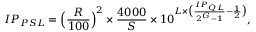<formula> <loc_0><loc_0><loc_500><loc_500>I P _ { P S L } = \left ( \frac { R } { 1 0 0 } \right ) ^ { 2 } \times \frac { 4 0 0 0 } { S } \times 1 0 ^ { L \times \left ( \frac { I P _ { Q L } } { 2 ^ { G } - 1 } - \frac { 1 } { 2 } \right ) } ,</formula> 